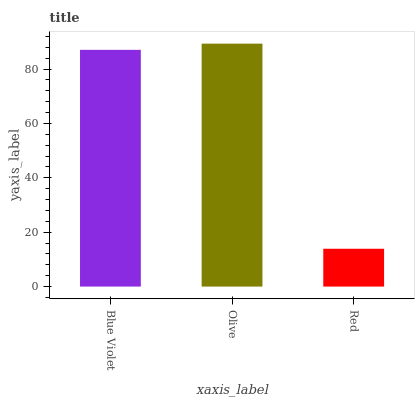Is Red the minimum?
Answer yes or no. Yes. Is Olive the maximum?
Answer yes or no. Yes. Is Olive the minimum?
Answer yes or no. No. Is Red the maximum?
Answer yes or no. No. Is Olive greater than Red?
Answer yes or no. Yes. Is Red less than Olive?
Answer yes or no. Yes. Is Red greater than Olive?
Answer yes or no. No. Is Olive less than Red?
Answer yes or no. No. Is Blue Violet the high median?
Answer yes or no. Yes. Is Blue Violet the low median?
Answer yes or no. Yes. Is Olive the high median?
Answer yes or no. No. Is Red the low median?
Answer yes or no. No. 